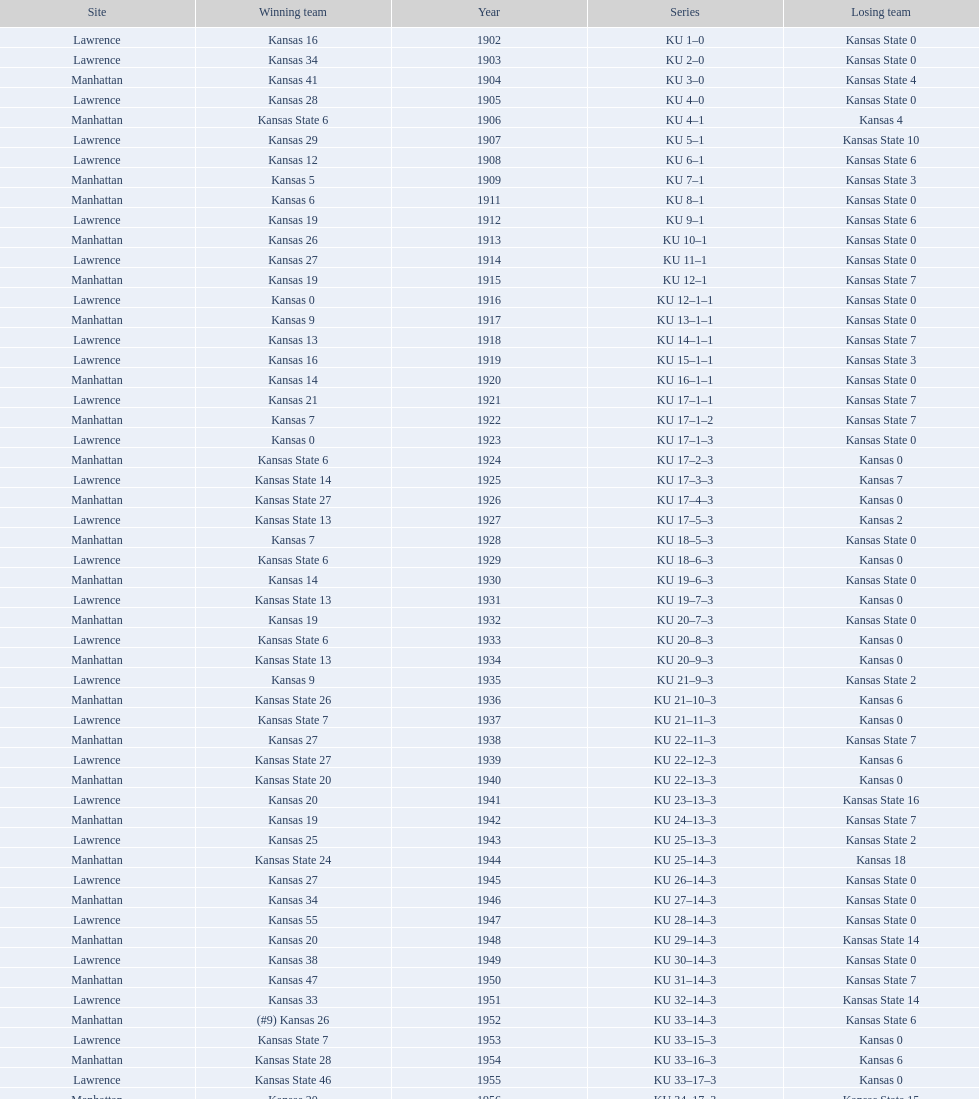What is the total number of games played? 66. 